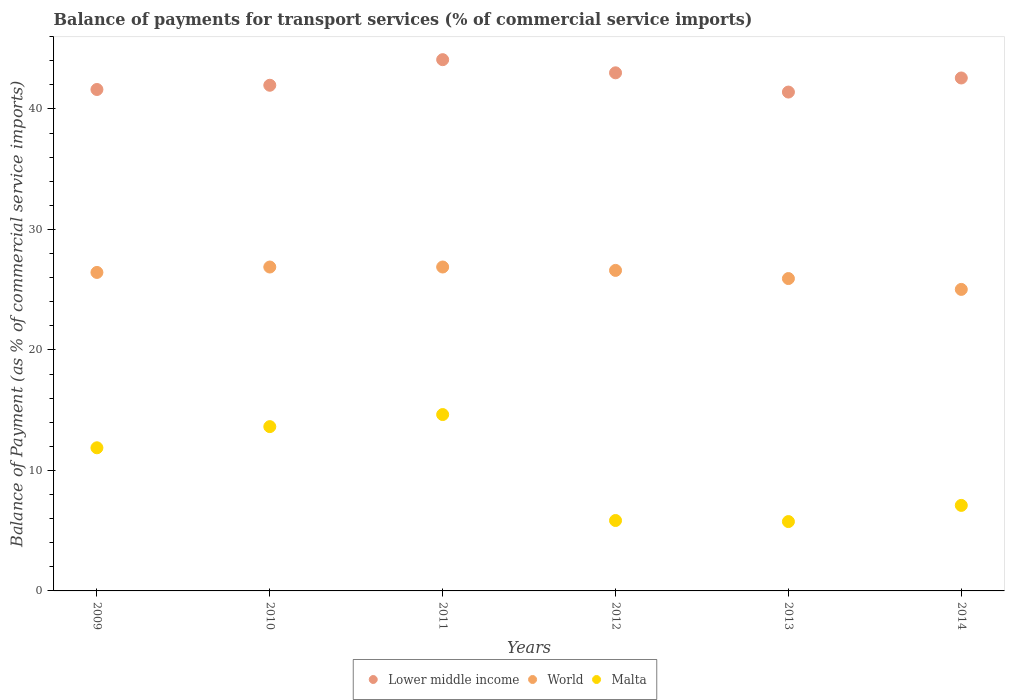How many different coloured dotlines are there?
Provide a succinct answer. 3. What is the balance of payments for transport services in Lower middle income in 2014?
Give a very brief answer. 42.57. Across all years, what is the maximum balance of payments for transport services in World?
Make the answer very short. 26.88. Across all years, what is the minimum balance of payments for transport services in Lower middle income?
Keep it short and to the point. 41.4. In which year was the balance of payments for transport services in Malta minimum?
Provide a succinct answer. 2013. What is the total balance of payments for transport services in Lower middle income in the graph?
Provide a short and direct response. 254.62. What is the difference between the balance of payments for transport services in Malta in 2010 and that in 2012?
Ensure brevity in your answer.  7.79. What is the difference between the balance of payments for transport services in Lower middle income in 2010 and the balance of payments for transport services in World in 2009?
Make the answer very short. 15.53. What is the average balance of payments for transport services in Malta per year?
Give a very brief answer. 9.81. In the year 2012, what is the difference between the balance of payments for transport services in World and balance of payments for transport services in Malta?
Make the answer very short. 20.76. What is the ratio of the balance of payments for transport services in World in 2013 to that in 2014?
Offer a very short reply. 1.04. Is the balance of payments for transport services in Lower middle income in 2010 less than that in 2012?
Ensure brevity in your answer.  Yes. What is the difference between the highest and the second highest balance of payments for transport services in Lower middle income?
Provide a short and direct response. 1.09. What is the difference between the highest and the lowest balance of payments for transport services in World?
Your response must be concise. 1.86. In how many years, is the balance of payments for transport services in Lower middle income greater than the average balance of payments for transport services in Lower middle income taken over all years?
Offer a very short reply. 3. How many years are there in the graph?
Offer a very short reply. 6. Are the values on the major ticks of Y-axis written in scientific E-notation?
Keep it short and to the point. No. Does the graph contain any zero values?
Provide a succinct answer. No. Where does the legend appear in the graph?
Provide a short and direct response. Bottom center. How many legend labels are there?
Your answer should be compact. 3. How are the legend labels stacked?
Make the answer very short. Horizontal. What is the title of the graph?
Provide a short and direct response. Balance of payments for transport services (% of commercial service imports). What is the label or title of the Y-axis?
Ensure brevity in your answer.  Balance of Payment (as % of commercial service imports). What is the Balance of Payment (as % of commercial service imports) in Lower middle income in 2009?
Give a very brief answer. 41.61. What is the Balance of Payment (as % of commercial service imports) of World in 2009?
Provide a short and direct response. 26.43. What is the Balance of Payment (as % of commercial service imports) in Malta in 2009?
Provide a succinct answer. 11.88. What is the Balance of Payment (as % of commercial service imports) of Lower middle income in 2010?
Your answer should be very brief. 41.96. What is the Balance of Payment (as % of commercial service imports) of World in 2010?
Provide a short and direct response. 26.88. What is the Balance of Payment (as % of commercial service imports) in Malta in 2010?
Provide a succinct answer. 13.63. What is the Balance of Payment (as % of commercial service imports) in Lower middle income in 2011?
Provide a succinct answer. 44.09. What is the Balance of Payment (as % of commercial service imports) of World in 2011?
Offer a very short reply. 26.88. What is the Balance of Payment (as % of commercial service imports) of Malta in 2011?
Your response must be concise. 14.64. What is the Balance of Payment (as % of commercial service imports) of Lower middle income in 2012?
Offer a terse response. 42.99. What is the Balance of Payment (as % of commercial service imports) of World in 2012?
Offer a very short reply. 26.6. What is the Balance of Payment (as % of commercial service imports) in Malta in 2012?
Ensure brevity in your answer.  5.84. What is the Balance of Payment (as % of commercial service imports) in Lower middle income in 2013?
Your answer should be very brief. 41.4. What is the Balance of Payment (as % of commercial service imports) in World in 2013?
Ensure brevity in your answer.  25.92. What is the Balance of Payment (as % of commercial service imports) of Malta in 2013?
Give a very brief answer. 5.75. What is the Balance of Payment (as % of commercial service imports) in Lower middle income in 2014?
Offer a very short reply. 42.57. What is the Balance of Payment (as % of commercial service imports) of World in 2014?
Your response must be concise. 25.02. What is the Balance of Payment (as % of commercial service imports) of Malta in 2014?
Your response must be concise. 7.1. Across all years, what is the maximum Balance of Payment (as % of commercial service imports) of Lower middle income?
Ensure brevity in your answer.  44.09. Across all years, what is the maximum Balance of Payment (as % of commercial service imports) of World?
Your answer should be very brief. 26.88. Across all years, what is the maximum Balance of Payment (as % of commercial service imports) in Malta?
Give a very brief answer. 14.64. Across all years, what is the minimum Balance of Payment (as % of commercial service imports) in Lower middle income?
Your answer should be very brief. 41.4. Across all years, what is the minimum Balance of Payment (as % of commercial service imports) of World?
Ensure brevity in your answer.  25.02. Across all years, what is the minimum Balance of Payment (as % of commercial service imports) in Malta?
Ensure brevity in your answer.  5.75. What is the total Balance of Payment (as % of commercial service imports) in Lower middle income in the graph?
Offer a very short reply. 254.62. What is the total Balance of Payment (as % of commercial service imports) of World in the graph?
Your answer should be very brief. 157.73. What is the total Balance of Payment (as % of commercial service imports) in Malta in the graph?
Keep it short and to the point. 58.84. What is the difference between the Balance of Payment (as % of commercial service imports) of Lower middle income in 2009 and that in 2010?
Offer a terse response. -0.35. What is the difference between the Balance of Payment (as % of commercial service imports) in World in 2009 and that in 2010?
Offer a very short reply. -0.45. What is the difference between the Balance of Payment (as % of commercial service imports) of Malta in 2009 and that in 2010?
Make the answer very short. -1.76. What is the difference between the Balance of Payment (as % of commercial service imports) of Lower middle income in 2009 and that in 2011?
Ensure brevity in your answer.  -2.47. What is the difference between the Balance of Payment (as % of commercial service imports) of World in 2009 and that in 2011?
Your response must be concise. -0.45. What is the difference between the Balance of Payment (as % of commercial service imports) of Malta in 2009 and that in 2011?
Your answer should be very brief. -2.76. What is the difference between the Balance of Payment (as % of commercial service imports) in Lower middle income in 2009 and that in 2012?
Keep it short and to the point. -1.38. What is the difference between the Balance of Payment (as % of commercial service imports) of World in 2009 and that in 2012?
Provide a succinct answer. -0.17. What is the difference between the Balance of Payment (as % of commercial service imports) in Malta in 2009 and that in 2012?
Your answer should be very brief. 6.03. What is the difference between the Balance of Payment (as % of commercial service imports) of Lower middle income in 2009 and that in 2013?
Provide a short and direct response. 0.21. What is the difference between the Balance of Payment (as % of commercial service imports) in World in 2009 and that in 2013?
Your answer should be compact. 0.51. What is the difference between the Balance of Payment (as % of commercial service imports) in Malta in 2009 and that in 2013?
Offer a terse response. 6.12. What is the difference between the Balance of Payment (as % of commercial service imports) of Lower middle income in 2009 and that in 2014?
Provide a succinct answer. -0.96. What is the difference between the Balance of Payment (as % of commercial service imports) in World in 2009 and that in 2014?
Give a very brief answer. 1.41. What is the difference between the Balance of Payment (as % of commercial service imports) in Malta in 2009 and that in 2014?
Keep it short and to the point. 4.78. What is the difference between the Balance of Payment (as % of commercial service imports) in Lower middle income in 2010 and that in 2011?
Offer a very short reply. -2.12. What is the difference between the Balance of Payment (as % of commercial service imports) of World in 2010 and that in 2011?
Your answer should be very brief. -0. What is the difference between the Balance of Payment (as % of commercial service imports) of Malta in 2010 and that in 2011?
Ensure brevity in your answer.  -1. What is the difference between the Balance of Payment (as % of commercial service imports) of Lower middle income in 2010 and that in 2012?
Give a very brief answer. -1.03. What is the difference between the Balance of Payment (as % of commercial service imports) of World in 2010 and that in 2012?
Your response must be concise. 0.28. What is the difference between the Balance of Payment (as % of commercial service imports) in Malta in 2010 and that in 2012?
Keep it short and to the point. 7.79. What is the difference between the Balance of Payment (as % of commercial service imports) in Lower middle income in 2010 and that in 2013?
Make the answer very short. 0.56. What is the difference between the Balance of Payment (as % of commercial service imports) of World in 2010 and that in 2013?
Your answer should be compact. 0.96. What is the difference between the Balance of Payment (as % of commercial service imports) in Malta in 2010 and that in 2013?
Give a very brief answer. 7.88. What is the difference between the Balance of Payment (as % of commercial service imports) in Lower middle income in 2010 and that in 2014?
Make the answer very short. -0.6. What is the difference between the Balance of Payment (as % of commercial service imports) of World in 2010 and that in 2014?
Ensure brevity in your answer.  1.86. What is the difference between the Balance of Payment (as % of commercial service imports) in Malta in 2010 and that in 2014?
Your answer should be very brief. 6.54. What is the difference between the Balance of Payment (as % of commercial service imports) in Lower middle income in 2011 and that in 2012?
Provide a short and direct response. 1.09. What is the difference between the Balance of Payment (as % of commercial service imports) of World in 2011 and that in 2012?
Offer a terse response. 0.28. What is the difference between the Balance of Payment (as % of commercial service imports) of Malta in 2011 and that in 2012?
Give a very brief answer. 8.79. What is the difference between the Balance of Payment (as % of commercial service imports) of Lower middle income in 2011 and that in 2013?
Give a very brief answer. 2.69. What is the difference between the Balance of Payment (as % of commercial service imports) of World in 2011 and that in 2013?
Keep it short and to the point. 0.96. What is the difference between the Balance of Payment (as % of commercial service imports) of Malta in 2011 and that in 2013?
Your answer should be very brief. 8.88. What is the difference between the Balance of Payment (as % of commercial service imports) in Lower middle income in 2011 and that in 2014?
Provide a succinct answer. 1.52. What is the difference between the Balance of Payment (as % of commercial service imports) in World in 2011 and that in 2014?
Offer a terse response. 1.86. What is the difference between the Balance of Payment (as % of commercial service imports) of Malta in 2011 and that in 2014?
Provide a succinct answer. 7.54. What is the difference between the Balance of Payment (as % of commercial service imports) in Lower middle income in 2012 and that in 2013?
Your response must be concise. 1.6. What is the difference between the Balance of Payment (as % of commercial service imports) in World in 2012 and that in 2013?
Your answer should be compact. 0.68. What is the difference between the Balance of Payment (as % of commercial service imports) in Malta in 2012 and that in 2013?
Offer a very short reply. 0.09. What is the difference between the Balance of Payment (as % of commercial service imports) in Lower middle income in 2012 and that in 2014?
Offer a very short reply. 0.43. What is the difference between the Balance of Payment (as % of commercial service imports) in World in 2012 and that in 2014?
Your response must be concise. 1.58. What is the difference between the Balance of Payment (as % of commercial service imports) of Malta in 2012 and that in 2014?
Offer a very short reply. -1.25. What is the difference between the Balance of Payment (as % of commercial service imports) of Lower middle income in 2013 and that in 2014?
Your answer should be very brief. -1.17. What is the difference between the Balance of Payment (as % of commercial service imports) in World in 2013 and that in 2014?
Provide a short and direct response. 0.9. What is the difference between the Balance of Payment (as % of commercial service imports) of Malta in 2013 and that in 2014?
Your answer should be compact. -1.34. What is the difference between the Balance of Payment (as % of commercial service imports) in Lower middle income in 2009 and the Balance of Payment (as % of commercial service imports) in World in 2010?
Provide a short and direct response. 14.73. What is the difference between the Balance of Payment (as % of commercial service imports) in Lower middle income in 2009 and the Balance of Payment (as % of commercial service imports) in Malta in 2010?
Provide a succinct answer. 27.98. What is the difference between the Balance of Payment (as % of commercial service imports) in World in 2009 and the Balance of Payment (as % of commercial service imports) in Malta in 2010?
Provide a short and direct response. 12.8. What is the difference between the Balance of Payment (as % of commercial service imports) of Lower middle income in 2009 and the Balance of Payment (as % of commercial service imports) of World in 2011?
Ensure brevity in your answer.  14.73. What is the difference between the Balance of Payment (as % of commercial service imports) of Lower middle income in 2009 and the Balance of Payment (as % of commercial service imports) of Malta in 2011?
Offer a terse response. 26.98. What is the difference between the Balance of Payment (as % of commercial service imports) in World in 2009 and the Balance of Payment (as % of commercial service imports) in Malta in 2011?
Ensure brevity in your answer.  11.79. What is the difference between the Balance of Payment (as % of commercial service imports) of Lower middle income in 2009 and the Balance of Payment (as % of commercial service imports) of World in 2012?
Offer a very short reply. 15.01. What is the difference between the Balance of Payment (as % of commercial service imports) of Lower middle income in 2009 and the Balance of Payment (as % of commercial service imports) of Malta in 2012?
Your answer should be very brief. 35.77. What is the difference between the Balance of Payment (as % of commercial service imports) of World in 2009 and the Balance of Payment (as % of commercial service imports) of Malta in 2012?
Your response must be concise. 20.59. What is the difference between the Balance of Payment (as % of commercial service imports) in Lower middle income in 2009 and the Balance of Payment (as % of commercial service imports) in World in 2013?
Make the answer very short. 15.69. What is the difference between the Balance of Payment (as % of commercial service imports) of Lower middle income in 2009 and the Balance of Payment (as % of commercial service imports) of Malta in 2013?
Your response must be concise. 35.86. What is the difference between the Balance of Payment (as % of commercial service imports) of World in 2009 and the Balance of Payment (as % of commercial service imports) of Malta in 2013?
Keep it short and to the point. 20.68. What is the difference between the Balance of Payment (as % of commercial service imports) in Lower middle income in 2009 and the Balance of Payment (as % of commercial service imports) in World in 2014?
Give a very brief answer. 16.59. What is the difference between the Balance of Payment (as % of commercial service imports) in Lower middle income in 2009 and the Balance of Payment (as % of commercial service imports) in Malta in 2014?
Your answer should be compact. 34.51. What is the difference between the Balance of Payment (as % of commercial service imports) of World in 2009 and the Balance of Payment (as % of commercial service imports) of Malta in 2014?
Keep it short and to the point. 19.33. What is the difference between the Balance of Payment (as % of commercial service imports) of Lower middle income in 2010 and the Balance of Payment (as % of commercial service imports) of World in 2011?
Ensure brevity in your answer.  15.08. What is the difference between the Balance of Payment (as % of commercial service imports) of Lower middle income in 2010 and the Balance of Payment (as % of commercial service imports) of Malta in 2011?
Offer a terse response. 27.33. What is the difference between the Balance of Payment (as % of commercial service imports) of World in 2010 and the Balance of Payment (as % of commercial service imports) of Malta in 2011?
Make the answer very short. 12.24. What is the difference between the Balance of Payment (as % of commercial service imports) in Lower middle income in 2010 and the Balance of Payment (as % of commercial service imports) in World in 2012?
Ensure brevity in your answer.  15.36. What is the difference between the Balance of Payment (as % of commercial service imports) in Lower middle income in 2010 and the Balance of Payment (as % of commercial service imports) in Malta in 2012?
Ensure brevity in your answer.  36.12. What is the difference between the Balance of Payment (as % of commercial service imports) in World in 2010 and the Balance of Payment (as % of commercial service imports) in Malta in 2012?
Your answer should be very brief. 21.04. What is the difference between the Balance of Payment (as % of commercial service imports) in Lower middle income in 2010 and the Balance of Payment (as % of commercial service imports) in World in 2013?
Offer a very short reply. 16.04. What is the difference between the Balance of Payment (as % of commercial service imports) in Lower middle income in 2010 and the Balance of Payment (as % of commercial service imports) in Malta in 2013?
Provide a succinct answer. 36.21. What is the difference between the Balance of Payment (as % of commercial service imports) in World in 2010 and the Balance of Payment (as % of commercial service imports) in Malta in 2013?
Offer a very short reply. 21.12. What is the difference between the Balance of Payment (as % of commercial service imports) of Lower middle income in 2010 and the Balance of Payment (as % of commercial service imports) of World in 2014?
Make the answer very short. 16.94. What is the difference between the Balance of Payment (as % of commercial service imports) of Lower middle income in 2010 and the Balance of Payment (as % of commercial service imports) of Malta in 2014?
Keep it short and to the point. 34.86. What is the difference between the Balance of Payment (as % of commercial service imports) in World in 2010 and the Balance of Payment (as % of commercial service imports) in Malta in 2014?
Give a very brief answer. 19.78. What is the difference between the Balance of Payment (as % of commercial service imports) in Lower middle income in 2011 and the Balance of Payment (as % of commercial service imports) in World in 2012?
Make the answer very short. 17.49. What is the difference between the Balance of Payment (as % of commercial service imports) of Lower middle income in 2011 and the Balance of Payment (as % of commercial service imports) of Malta in 2012?
Make the answer very short. 38.24. What is the difference between the Balance of Payment (as % of commercial service imports) of World in 2011 and the Balance of Payment (as % of commercial service imports) of Malta in 2012?
Give a very brief answer. 21.04. What is the difference between the Balance of Payment (as % of commercial service imports) of Lower middle income in 2011 and the Balance of Payment (as % of commercial service imports) of World in 2013?
Your answer should be compact. 18.16. What is the difference between the Balance of Payment (as % of commercial service imports) of Lower middle income in 2011 and the Balance of Payment (as % of commercial service imports) of Malta in 2013?
Offer a terse response. 38.33. What is the difference between the Balance of Payment (as % of commercial service imports) of World in 2011 and the Balance of Payment (as % of commercial service imports) of Malta in 2013?
Your answer should be very brief. 21.13. What is the difference between the Balance of Payment (as % of commercial service imports) in Lower middle income in 2011 and the Balance of Payment (as % of commercial service imports) in World in 2014?
Your answer should be compact. 19.06. What is the difference between the Balance of Payment (as % of commercial service imports) in Lower middle income in 2011 and the Balance of Payment (as % of commercial service imports) in Malta in 2014?
Ensure brevity in your answer.  36.99. What is the difference between the Balance of Payment (as % of commercial service imports) of World in 2011 and the Balance of Payment (as % of commercial service imports) of Malta in 2014?
Provide a short and direct response. 19.78. What is the difference between the Balance of Payment (as % of commercial service imports) of Lower middle income in 2012 and the Balance of Payment (as % of commercial service imports) of World in 2013?
Ensure brevity in your answer.  17.07. What is the difference between the Balance of Payment (as % of commercial service imports) of Lower middle income in 2012 and the Balance of Payment (as % of commercial service imports) of Malta in 2013?
Provide a short and direct response. 37.24. What is the difference between the Balance of Payment (as % of commercial service imports) of World in 2012 and the Balance of Payment (as % of commercial service imports) of Malta in 2013?
Provide a short and direct response. 20.84. What is the difference between the Balance of Payment (as % of commercial service imports) of Lower middle income in 2012 and the Balance of Payment (as % of commercial service imports) of World in 2014?
Give a very brief answer. 17.97. What is the difference between the Balance of Payment (as % of commercial service imports) in Lower middle income in 2012 and the Balance of Payment (as % of commercial service imports) in Malta in 2014?
Make the answer very short. 35.9. What is the difference between the Balance of Payment (as % of commercial service imports) in World in 2012 and the Balance of Payment (as % of commercial service imports) in Malta in 2014?
Your answer should be very brief. 19.5. What is the difference between the Balance of Payment (as % of commercial service imports) in Lower middle income in 2013 and the Balance of Payment (as % of commercial service imports) in World in 2014?
Your answer should be compact. 16.38. What is the difference between the Balance of Payment (as % of commercial service imports) in Lower middle income in 2013 and the Balance of Payment (as % of commercial service imports) in Malta in 2014?
Your answer should be compact. 34.3. What is the difference between the Balance of Payment (as % of commercial service imports) in World in 2013 and the Balance of Payment (as % of commercial service imports) in Malta in 2014?
Keep it short and to the point. 18.82. What is the average Balance of Payment (as % of commercial service imports) in Lower middle income per year?
Ensure brevity in your answer.  42.44. What is the average Balance of Payment (as % of commercial service imports) of World per year?
Provide a short and direct response. 26.29. What is the average Balance of Payment (as % of commercial service imports) of Malta per year?
Offer a very short reply. 9.81. In the year 2009, what is the difference between the Balance of Payment (as % of commercial service imports) in Lower middle income and Balance of Payment (as % of commercial service imports) in World?
Ensure brevity in your answer.  15.18. In the year 2009, what is the difference between the Balance of Payment (as % of commercial service imports) of Lower middle income and Balance of Payment (as % of commercial service imports) of Malta?
Keep it short and to the point. 29.73. In the year 2009, what is the difference between the Balance of Payment (as % of commercial service imports) in World and Balance of Payment (as % of commercial service imports) in Malta?
Your response must be concise. 14.55. In the year 2010, what is the difference between the Balance of Payment (as % of commercial service imports) in Lower middle income and Balance of Payment (as % of commercial service imports) in World?
Your answer should be compact. 15.08. In the year 2010, what is the difference between the Balance of Payment (as % of commercial service imports) of Lower middle income and Balance of Payment (as % of commercial service imports) of Malta?
Provide a succinct answer. 28.33. In the year 2010, what is the difference between the Balance of Payment (as % of commercial service imports) in World and Balance of Payment (as % of commercial service imports) in Malta?
Your answer should be compact. 13.24. In the year 2011, what is the difference between the Balance of Payment (as % of commercial service imports) of Lower middle income and Balance of Payment (as % of commercial service imports) of World?
Offer a terse response. 17.21. In the year 2011, what is the difference between the Balance of Payment (as % of commercial service imports) of Lower middle income and Balance of Payment (as % of commercial service imports) of Malta?
Provide a short and direct response. 29.45. In the year 2011, what is the difference between the Balance of Payment (as % of commercial service imports) in World and Balance of Payment (as % of commercial service imports) in Malta?
Offer a very short reply. 12.24. In the year 2012, what is the difference between the Balance of Payment (as % of commercial service imports) in Lower middle income and Balance of Payment (as % of commercial service imports) in World?
Offer a very short reply. 16.4. In the year 2012, what is the difference between the Balance of Payment (as % of commercial service imports) in Lower middle income and Balance of Payment (as % of commercial service imports) in Malta?
Provide a short and direct response. 37.15. In the year 2012, what is the difference between the Balance of Payment (as % of commercial service imports) of World and Balance of Payment (as % of commercial service imports) of Malta?
Give a very brief answer. 20.76. In the year 2013, what is the difference between the Balance of Payment (as % of commercial service imports) in Lower middle income and Balance of Payment (as % of commercial service imports) in World?
Keep it short and to the point. 15.48. In the year 2013, what is the difference between the Balance of Payment (as % of commercial service imports) of Lower middle income and Balance of Payment (as % of commercial service imports) of Malta?
Give a very brief answer. 35.64. In the year 2013, what is the difference between the Balance of Payment (as % of commercial service imports) of World and Balance of Payment (as % of commercial service imports) of Malta?
Your answer should be compact. 20.17. In the year 2014, what is the difference between the Balance of Payment (as % of commercial service imports) in Lower middle income and Balance of Payment (as % of commercial service imports) in World?
Make the answer very short. 17.55. In the year 2014, what is the difference between the Balance of Payment (as % of commercial service imports) of Lower middle income and Balance of Payment (as % of commercial service imports) of Malta?
Your answer should be very brief. 35.47. In the year 2014, what is the difference between the Balance of Payment (as % of commercial service imports) of World and Balance of Payment (as % of commercial service imports) of Malta?
Your answer should be very brief. 17.92. What is the ratio of the Balance of Payment (as % of commercial service imports) of Lower middle income in 2009 to that in 2010?
Provide a succinct answer. 0.99. What is the ratio of the Balance of Payment (as % of commercial service imports) of World in 2009 to that in 2010?
Make the answer very short. 0.98. What is the ratio of the Balance of Payment (as % of commercial service imports) of Malta in 2009 to that in 2010?
Your answer should be very brief. 0.87. What is the ratio of the Balance of Payment (as % of commercial service imports) in Lower middle income in 2009 to that in 2011?
Make the answer very short. 0.94. What is the ratio of the Balance of Payment (as % of commercial service imports) in World in 2009 to that in 2011?
Offer a terse response. 0.98. What is the ratio of the Balance of Payment (as % of commercial service imports) of Malta in 2009 to that in 2011?
Your answer should be very brief. 0.81. What is the ratio of the Balance of Payment (as % of commercial service imports) of Lower middle income in 2009 to that in 2012?
Make the answer very short. 0.97. What is the ratio of the Balance of Payment (as % of commercial service imports) of World in 2009 to that in 2012?
Provide a short and direct response. 0.99. What is the ratio of the Balance of Payment (as % of commercial service imports) in Malta in 2009 to that in 2012?
Keep it short and to the point. 2.03. What is the ratio of the Balance of Payment (as % of commercial service imports) in World in 2009 to that in 2013?
Keep it short and to the point. 1.02. What is the ratio of the Balance of Payment (as % of commercial service imports) in Malta in 2009 to that in 2013?
Give a very brief answer. 2.06. What is the ratio of the Balance of Payment (as % of commercial service imports) of Lower middle income in 2009 to that in 2014?
Keep it short and to the point. 0.98. What is the ratio of the Balance of Payment (as % of commercial service imports) in World in 2009 to that in 2014?
Offer a very short reply. 1.06. What is the ratio of the Balance of Payment (as % of commercial service imports) in Malta in 2009 to that in 2014?
Provide a short and direct response. 1.67. What is the ratio of the Balance of Payment (as % of commercial service imports) in Lower middle income in 2010 to that in 2011?
Provide a short and direct response. 0.95. What is the ratio of the Balance of Payment (as % of commercial service imports) in World in 2010 to that in 2011?
Your response must be concise. 1. What is the ratio of the Balance of Payment (as % of commercial service imports) of Malta in 2010 to that in 2011?
Offer a terse response. 0.93. What is the ratio of the Balance of Payment (as % of commercial service imports) in World in 2010 to that in 2012?
Your answer should be compact. 1.01. What is the ratio of the Balance of Payment (as % of commercial service imports) in Malta in 2010 to that in 2012?
Offer a terse response. 2.33. What is the ratio of the Balance of Payment (as % of commercial service imports) in Lower middle income in 2010 to that in 2013?
Make the answer very short. 1.01. What is the ratio of the Balance of Payment (as % of commercial service imports) of World in 2010 to that in 2013?
Offer a very short reply. 1.04. What is the ratio of the Balance of Payment (as % of commercial service imports) of Malta in 2010 to that in 2013?
Keep it short and to the point. 2.37. What is the ratio of the Balance of Payment (as % of commercial service imports) in Lower middle income in 2010 to that in 2014?
Provide a short and direct response. 0.99. What is the ratio of the Balance of Payment (as % of commercial service imports) in World in 2010 to that in 2014?
Offer a terse response. 1.07. What is the ratio of the Balance of Payment (as % of commercial service imports) of Malta in 2010 to that in 2014?
Your answer should be very brief. 1.92. What is the ratio of the Balance of Payment (as % of commercial service imports) of Lower middle income in 2011 to that in 2012?
Your answer should be compact. 1.03. What is the ratio of the Balance of Payment (as % of commercial service imports) of World in 2011 to that in 2012?
Your answer should be compact. 1.01. What is the ratio of the Balance of Payment (as % of commercial service imports) in Malta in 2011 to that in 2012?
Your response must be concise. 2.5. What is the ratio of the Balance of Payment (as % of commercial service imports) in Lower middle income in 2011 to that in 2013?
Provide a succinct answer. 1.06. What is the ratio of the Balance of Payment (as % of commercial service imports) of World in 2011 to that in 2013?
Your response must be concise. 1.04. What is the ratio of the Balance of Payment (as % of commercial service imports) of Malta in 2011 to that in 2013?
Provide a short and direct response. 2.54. What is the ratio of the Balance of Payment (as % of commercial service imports) of Lower middle income in 2011 to that in 2014?
Your response must be concise. 1.04. What is the ratio of the Balance of Payment (as % of commercial service imports) of World in 2011 to that in 2014?
Make the answer very short. 1.07. What is the ratio of the Balance of Payment (as % of commercial service imports) of Malta in 2011 to that in 2014?
Offer a very short reply. 2.06. What is the ratio of the Balance of Payment (as % of commercial service imports) in Lower middle income in 2012 to that in 2013?
Provide a short and direct response. 1.04. What is the ratio of the Balance of Payment (as % of commercial service imports) of World in 2012 to that in 2013?
Your answer should be very brief. 1.03. What is the ratio of the Balance of Payment (as % of commercial service imports) of Malta in 2012 to that in 2013?
Give a very brief answer. 1.02. What is the ratio of the Balance of Payment (as % of commercial service imports) of World in 2012 to that in 2014?
Your response must be concise. 1.06. What is the ratio of the Balance of Payment (as % of commercial service imports) of Malta in 2012 to that in 2014?
Keep it short and to the point. 0.82. What is the ratio of the Balance of Payment (as % of commercial service imports) of Lower middle income in 2013 to that in 2014?
Your answer should be very brief. 0.97. What is the ratio of the Balance of Payment (as % of commercial service imports) of World in 2013 to that in 2014?
Provide a succinct answer. 1.04. What is the ratio of the Balance of Payment (as % of commercial service imports) of Malta in 2013 to that in 2014?
Provide a succinct answer. 0.81. What is the difference between the highest and the second highest Balance of Payment (as % of commercial service imports) in Lower middle income?
Your answer should be compact. 1.09. What is the difference between the highest and the second highest Balance of Payment (as % of commercial service imports) in World?
Your response must be concise. 0. What is the difference between the highest and the lowest Balance of Payment (as % of commercial service imports) of Lower middle income?
Your response must be concise. 2.69. What is the difference between the highest and the lowest Balance of Payment (as % of commercial service imports) of World?
Provide a succinct answer. 1.86. What is the difference between the highest and the lowest Balance of Payment (as % of commercial service imports) in Malta?
Provide a short and direct response. 8.88. 